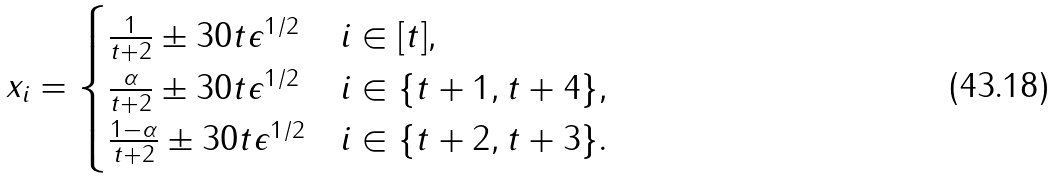Convert formula to latex. <formula><loc_0><loc_0><loc_500><loc_500>x _ { i } = \begin{cases} \frac { 1 } { t + 2 } \pm 3 0 t \epsilon ^ { 1 / 2 } & i \in [ t ] , \\ \frac { \alpha } { t + 2 } \pm 3 0 t \epsilon ^ { 1 / 2 } & i \in \{ t + 1 , t + 4 \} , \\ \frac { 1 - \alpha } { t + 2 } \pm 3 0 t \epsilon ^ { 1 / 2 } & i \in \{ t + 2 , t + 3 \} . \end{cases}</formula> 